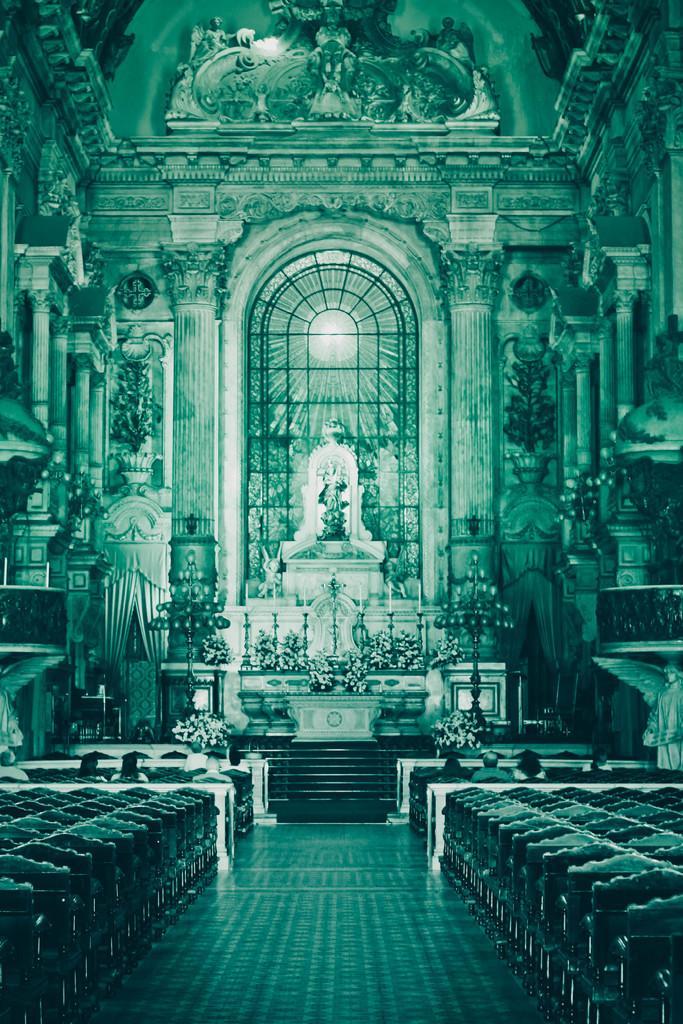Describe this image in one or two sentences. In this image we can see an inside view of a church, there are pillars, there is a wall, there are sculptures on the wall, there is a staircase, there is floor towards the bottom of the image, there are chairs towards the right of the image, there are chairs towards the left of the image, there are persons sitting on the chairs, there are plants, there are pillars, there are curtains. 